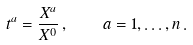<formula> <loc_0><loc_0><loc_500><loc_500>t ^ { a } = \frac { X ^ { a } } { X ^ { 0 } } \, , \quad a = 1 , \dots , n \, .</formula> 